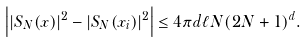<formula> <loc_0><loc_0><loc_500><loc_500>\left | | S _ { N } ( x ) | ^ { 2 } - | S _ { N } ( x _ { i } ) | ^ { 2 } \right | \leq 4 \pi d \ell N ( 2 N + 1 ) ^ { d } .</formula> 